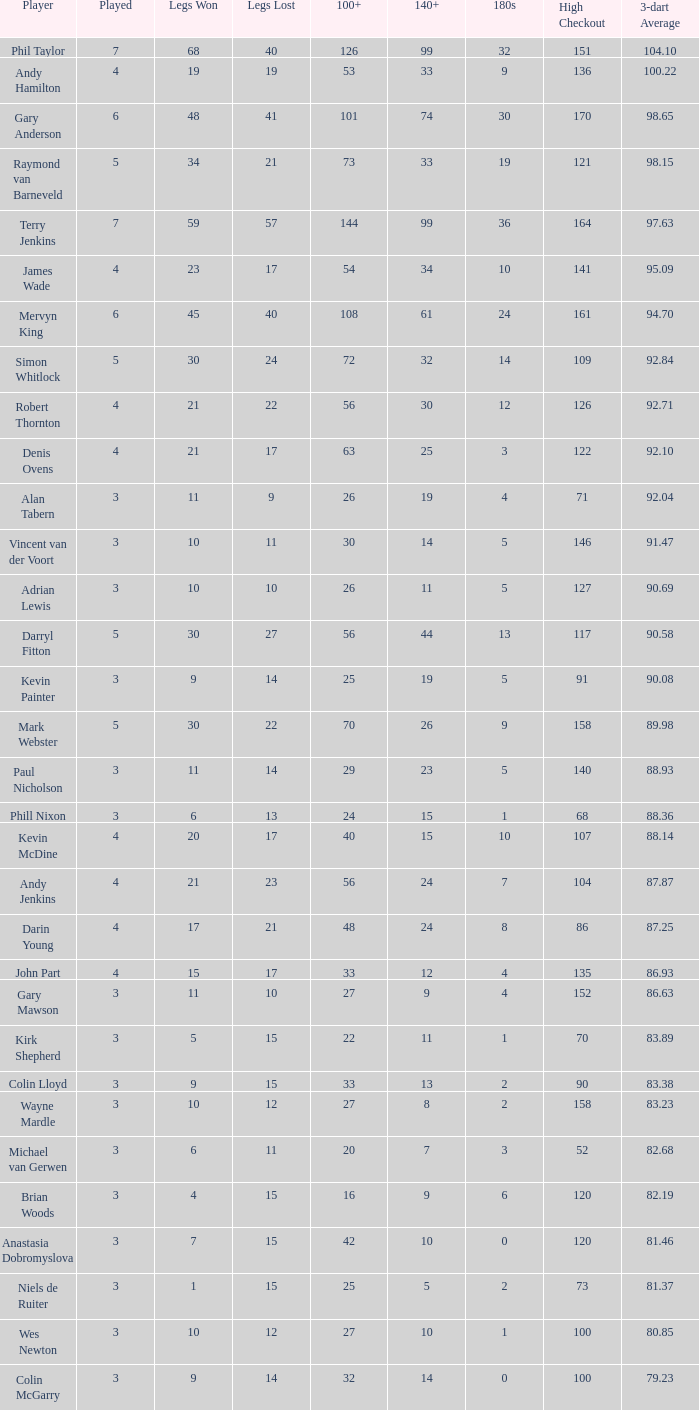What is the high checkout when Legs Won is smaller than 9, a 180s of 1, and a 3-dart Average larger than 88.36? None. Can you give me this table as a dict? {'header': ['Player', 'Played', 'Legs Won', 'Legs Lost', '100+', '140+', '180s', 'High Checkout', '3-dart Average'], 'rows': [['Phil Taylor', '7', '68', '40', '126', '99', '32', '151', '104.10'], ['Andy Hamilton', '4', '19', '19', '53', '33', '9', '136', '100.22'], ['Gary Anderson', '6', '48', '41', '101', '74', '30', '170', '98.65'], ['Raymond van Barneveld', '5', '34', '21', '73', '33', '19', '121', '98.15'], ['Terry Jenkins', '7', '59', '57', '144', '99', '36', '164', '97.63'], ['James Wade', '4', '23', '17', '54', '34', '10', '141', '95.09'], ['Mervyn King', '6', '45', '40', '108', '61', '24', '161', '94.70'], ['Simon Whitlock', '5', '30', '24', '72', '32', '14', '109', '92.84'], ['Robert Thornton', '4', '21', '22', '56', '30', '12', '126', '92.71'], ['Denis Ovens', '4', '21', '17', '63', '25', '3', '122', '92.10'], ['Alan Tabern', '3', '11', '9', '26', '19', '4', '71', '92.04'], ['Vincent van der Voort', '3', '10', '11', '30', '14', '5', '146', '91.47'], ['Adrian Lewis', '3', '10', '10', '26', '11', '5', '127', '90.69'], ['Darryl Fitton', '5', '30', '27', '56', '44', '13', '117', '90.58'], ['Kevin Painter', '3', '9', '14', '25', '19', '5', '91', '90.08'], ['Mark Webster', '5', '30', '22', '70', '26', '9', '158', '89.98'], ['Paul Nicholson', '3', '11', '14', '29', '23', '5', '140', '88.93'], ['Phill Nixon', '3', '6', '13', '24', '15', '1', '68', '88.36'], ['Kevin McDine', '4', '20', '17', '40', '15', '10', '107', '88.14'], ['Andy Jenkins', '4', '21', '23', '56', '24', '7', '104', '87.87'], ['Darin Young', '4', '17', '21', '48', '24', '8', '86', '87.25'], ['John Part', '4', '15', '17', '33', '12', '4', '135', '86.93'], ['Gary Mawson', '3', '11', '10', '27', '9', '4', '152', '86.63'], ['Kirk Shepherd', '3', '5', '15', '22', '11', '1', '70', '83.89'], ['Colin Lloyd', '3', '9', '15', '33', '13', '2', '90', '83.38'], ['Wayne Mardle', '3', '10', '12', '27', '8', '2', '158', '83.23'], ['Michael van Gerwen', '3', '6', '11', '20', '7', '3', '52', '82.68'], ['Brian Woods', '3', '4', '15', '16', '9', '6', '120', '82.19'], ['Anastasia Dobromyslova', '3', '7', '15', '42', '10', '0', '120', '81.46'], ['Niels de Ruiter', '3', '1', '15', '25', '5', '2', '73', '81.37'], ['Wes Newton', '3', '10', '12', '27', '10', '1', '100', '80.85'], ['Colin McGarry', '3', '9', '14', '32', '14', '0', '100', '79.23']]} 